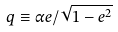Convert formula to latex. <formula><loc_0><loc_0><loc_500><loc_500>q \equiv \alpha e / \sqrt { 1 - e ^ { 2 } }</formula> 